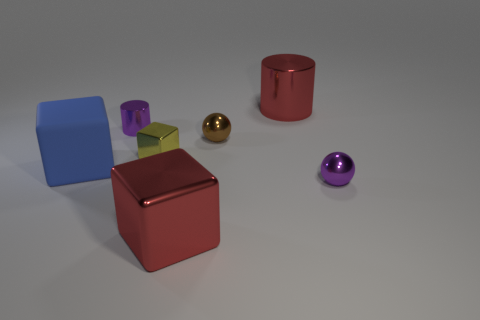Is there anything else that is the same material as the big blue thing?
Provide a succinct answer. No. There is a red object in front of the matte thing that is to the left of the brown object; what is it made of?
Keep it short and to the point. Metal. Is the number of tiny spheres behind the yellow metal cube greater than the number of purple metallic balls behind the tiny metal cylinder?
Provide a succinct answer. Yes. The red block has what size?
Your answer should be compact. Large. There is a small shiny thing in front of the yellow block; is its color the same as the tiny metallic cylinder?
Offer a terse response. Yes. Are there any other things that are the same shape as the small yellow metallic thing?
Keep it short and to the point. Yes. There is a small purple metal cylinder that is behind the tiny block; are there any blue rubber cubes that are behind it?
Offer a very short reply. No. Is the number of purple shiny cylinders in front of the red metal block less than the number of red cylinders in front of the brown thing?
Your answer should be compact. No. There is a blue thing that is behind the big shiny object in front of the small metal sphere on the left side of the big red metallic cylinder; how big is it?
Your answer should be compact. Large. There is a metal ball that is in front of the blue block; does it have the same size as the tiny cube?
Offer a very short reply. Yes. 